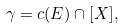<formula> <loc_0><loc_0><loc_500><loc_500>\gamma = c ( E ) \cap [ X ] ,</formula> 